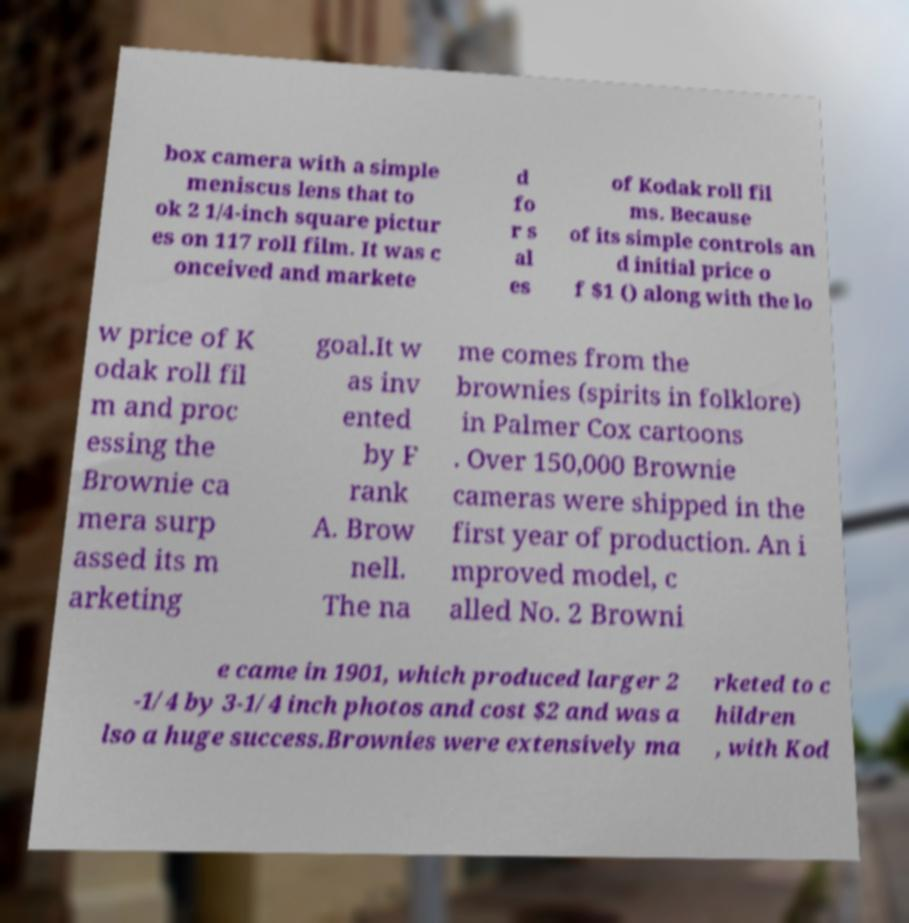Can you accurately transcribe the text from the provided image for me? box camera with a simple meniscus lens that to ok 2 1/4-inch square pictur es on 117 roll film. It was c onceived and markete d fo r s al es of Kodak roll fil ms. Because of its simple controls an d initial price o f $1 () along with the lo w price of K odak roll fil m and proc essing the Brownie ca mera surp assed its m arketing goal.It w as inv ented by F rank A. Brow nell. The na me comes from the brownies (spirits in folklore) in Palmer Cox cartoons . Over 150,000 Brownie cameras were shipped in the first year of production. An i mproved model, c alled No. 2 Browni e came in 1901, which produced larger 2 -1/4 by 3-1/4 inch photos and cost $2 and was a lso a huge success.Brownies were extensively ma rketed to c hildren , with Kod 